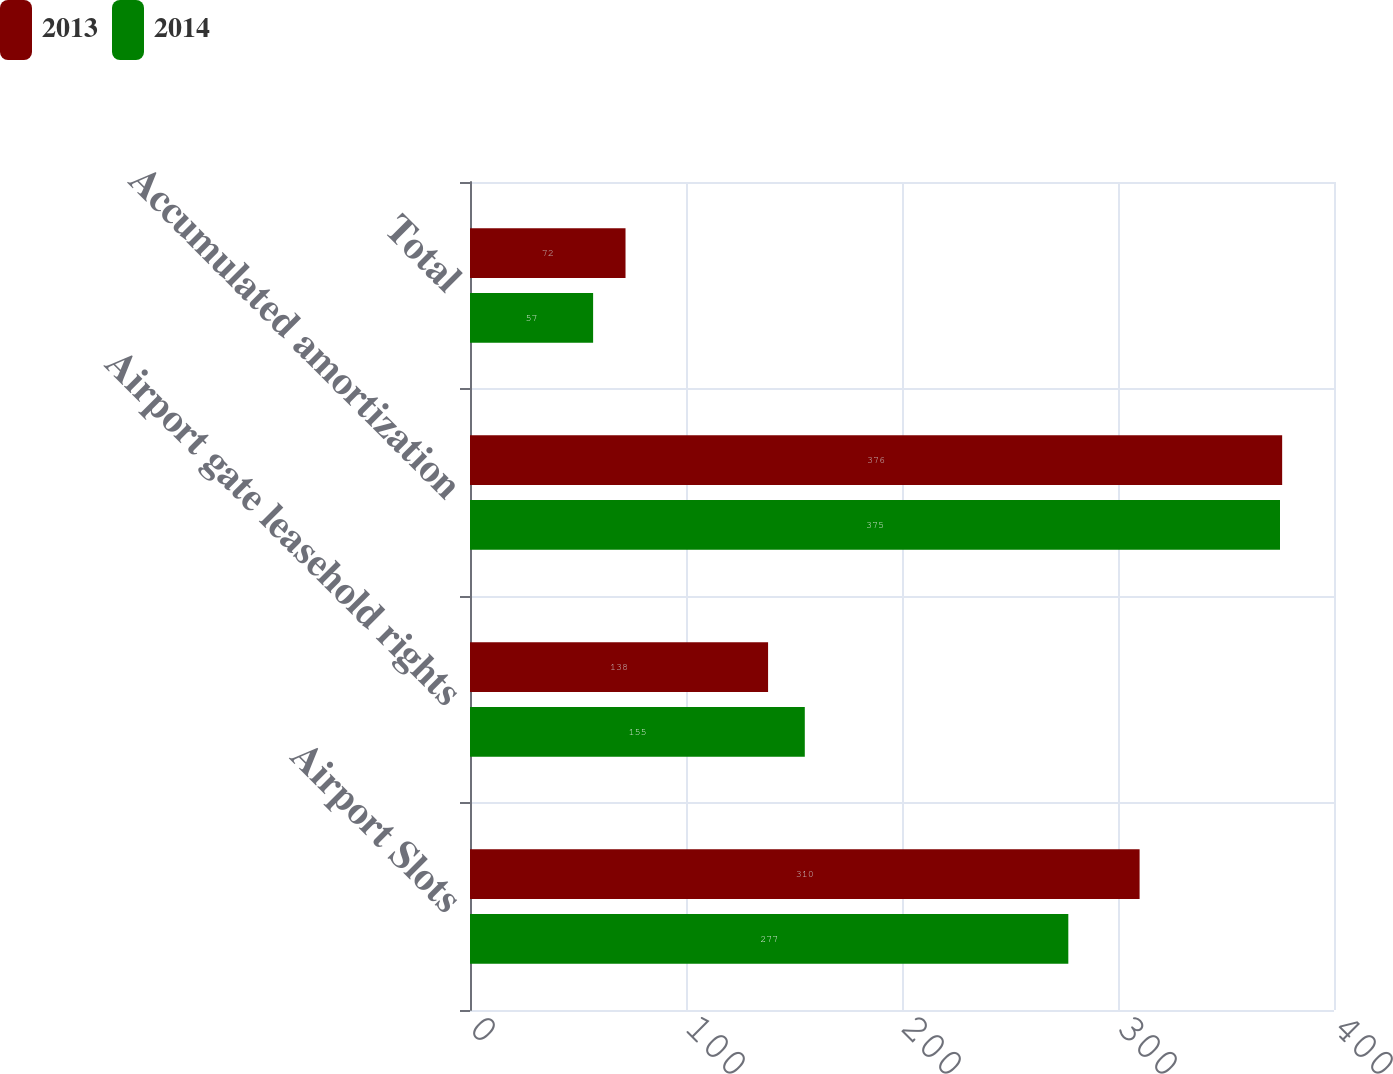Convert chart. <chart><loc_0><loc_0><loc_500><loc_500><stacked_bar_chart><ecel><fcel>Airport Slots<fcel>Airport gate leasehold rights<fcel>Accumulated amortization<fcel>Total<nl><fcel>2013<fcel>310<fcel>138<fcel>376<fcel>72<nl><fcel>2014<fcel>277<fcel>155<fcel>375<fcel>57<nl></chart> 